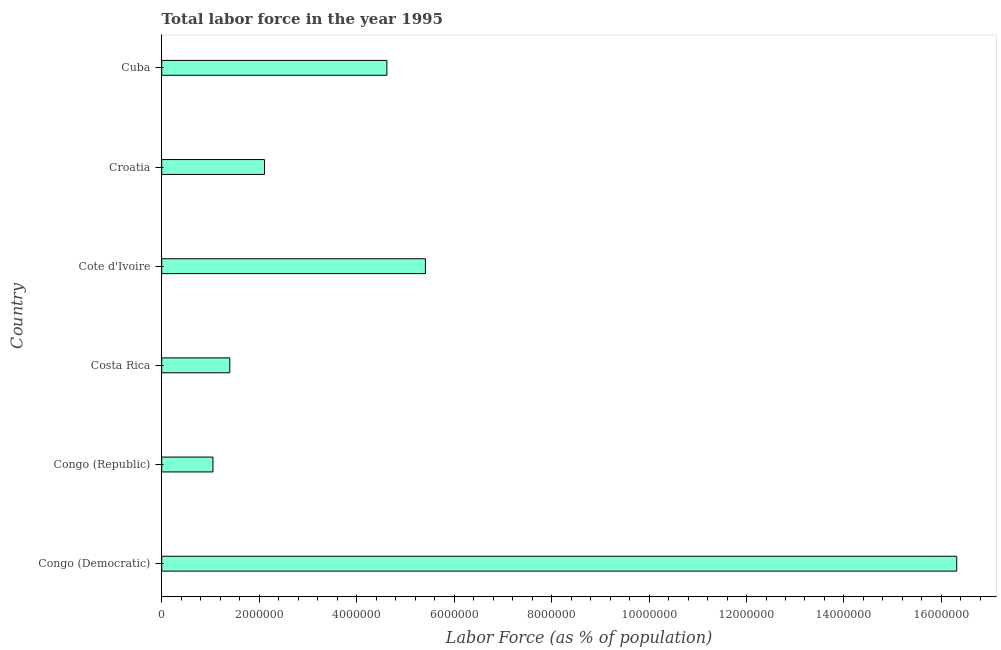Does the graph contain any zero values?
Offer a terse response. No. What is the title of the graph?
Ensure brevity in your answer.  Total labor force in the year 1995. What is the label or title of the X-axis?
Provide a short and direct response. Labor Force (as % of population). What is the label or title of the Y-axis?
Give a very brief answer. Country. What is the total labor force in Cuba?
Give a very brief answer. 4.62e+06. Across all countries, what is the maximum total labor force?
Offer a terse response. 1.63e+07. Across all countries, what is the minimum total labor force?
Your response must be concise. 1.05e+06. In which country was the total labor force maximum?
Offer a terse response. Congo (Democratic). In which country was the total labor force minimum?
Ensure brevity in your answer.  Congo (Republic). What is the sum of the total labor force?
Provide a succinct answer. 3.09e+07. What is the difference between the total labor force in Costa Rica and Croatia?
Ensure brevity in your answer.  -7.12e+05. What is the average total labor force per country?
Provide a short and direct response. 5.15e+06. What is the median total labor force?
Your answer should be very brief. 3.36e+06. In how many countries, is the total labor force greater than 13600000 %?
Offer a very short reply. 1. What is the ratio of the total labor force in Costa Rica to that in Cote d'Ivoire?
Give a very brief answer. 0.26. Is the total labor force in Congo (Republic) less than that in Croatia?
Offer a very short reply. Yes. Is the difference between the total labor force in Congo (Democratic) and Croatia greater than the difference between any two countries?
Provide a succinct answer. No. What is the difference between the highest and the second highest total labor force?
Give a very brief answer. 1.09e+07. What is the difference between the highest and the lowest total labor force?
Offer a terse response. 1.53e+07. In how many countries, is the total labor force greater than the average total labor force taken over all countries?
Offer a terse response. 2. How many bars are there?
Provide a succinct answer. 6. How many countries are there in the graph?
Keep it short and to the point. 6. What is the difference between two consecutive major ticks on the X-axis?
Your answer should be compact. 2.00e+06. What is the Labor Force (as % of population) of Congo (Democratic)?
Offer a terse response. 1.63e+07. What is the Labor Force (as % of population) in Congo (Republic)?
Provide a succinct answer. 1.05e+06. What is the Labor Force (as % of population) of Costa Rica?
Offer a very short reply. 1.40e+06. What is the Labor Force (as % of population) of Cote d'Ivoire?
Ensure brevity in your answer.  5.41e+06. What is the Labor Force (as % of population) of Croatia?
Your response must be concise. 2.11e+06. What is the Labor Force (as % of population) in Cuba?
Your answer should be compact. 4.62e+06. What is the difference between the Labor Force (as % of population) in Congo (Democratic) and Congo (Republic)?
Provide a short and direct response. 1.53e+07. What is the difference between the Labor Force (as % of population) in Congo (Democratic) and Costa Rica?
Offer a very short reply. 1.49e+07. What is the difference between the Labor Force (as % of population) in Congo (Democratic) and Cote d'Ivoire?
Make the answer very short. 1.09e+07. What is the difference between the Labor Force (as % of population) in Congo (Democratic) and Croatia?
Make the answer very short. 1.42e+07. What is the difference between the Labor Force (as % of population) in Congo (Democratic) and Cuba?
Give a very brief answer. 1.17e+07. What is the difference between the Labor Force (as % of population) in Congo (Republic) and Costa Rica?
Keep it short and to the point. -3.45e+05. What is the difference between the Labor Force (as % of population) in Congo (Republic) and Cote d'Ivoire?
Your response must be concise. -4.36e+06. What is the difference between the Labor Force (as % of population) in Congo (Republic) and Croatia?
Provide a short and direct response. -1.06e+06. What is the difference between the Labor Force (as % of population) in Congo (Republic) and Cuba?
Make the answer very short. -3.57e+06. What is the difference between the Labor Force (as % of population) in Costa Rica and Cote d'Ivoire?
Give a very brief answer. -4.01e+06. What is the difference between the Labor Force (as % of population) in Costa Rica and Croatia?
Offer a very short reply. -7.12e+05. What is the difference between the Labor Force (as % of population) in Costa Rica and Cuba?
Provide a succinct answer. -3.22e+06. What is the difference between the Labor Force (as % of population) in Cote d'Ivoire and Croatia?
Your answer should be compact. 3.30e+06. What is the difference between the Labor Force (as % of population) in Cote d'Ivoire and Cuba?
Make the answer very short. 7.91e+05. What is the difference between the Labor Force (as % of population) in Croatia and Cuba?
Offer a very short reply. -2.51e+06. What is the ratio of the Labor Force (as % of population) in Congo (Democratic) to that in Congo (Republic)?
Give a very brief answer. 15.51. What is the ratio of the Labor Force (as % of population) in Congo (Democratic) to that in Costa Rica?
Provide a succinct answer. 11.68. What is the ratio of the Labor Force (as % of population) in Congo (Democratic) to that in Cote d'Ivoire?
Provide a short and direct response. 3.02. What is the ratio of the Labor Force (as % of population) in Congo (Democratic) to that in Croatia?
Offer a very short reply. 7.73. What is the ratio of the Labor Force (as % of population) in Congo (Democratic) to that in Cuba?
Offer a very short reply. 3.53. What is the ratio of the Labor Force (as % of population) in Congo (Republic) to that in Costa Rica?
Make the answer very short. 0.75. What is the ratio of the Labor Force (as % of population) in Congo (Republic) to that in Cote d'Ivoire?
Keep it short and to the point. 0.19. What is the ratio of the Labor Force (as % of population) in Congo (Republic) to that in Croatia?
Your answer should be very brief. 0.5. What is the ratio of the Labor Force (as % of population) in Congo (Republic) to that in Cuba?
Ensure brevity in your answer.  0.23. What is the ratio of the Labor Force (as % of population) in Costa Rica to that in Cote d'Ivoire?
Keep it short and to the point. 0.26. What is the ratio of the Labor Force (as % of population) in Costa Rica to that in Croatia?
Your answer should be very brief. 0.66. What is the ratio of the Labor Force (as % of population) in Costa Rica to that in Cuba?
Ensure brevity in your answer.  0.3. What is the ratio of the Labor Force (as % of population) in Cote d'Ivoire to that in Croatia?
Your answer should be compact. 2.56. What is the ratio of the Labor Force (as % of population) in Cote d'Ivoire to that in Cuba?
Your answer should be very brief. 1.17. What is the ratio of the Labor Force (as % of population) in Croatia to that in Cuba?
Give a very brief answer. 0.46. 